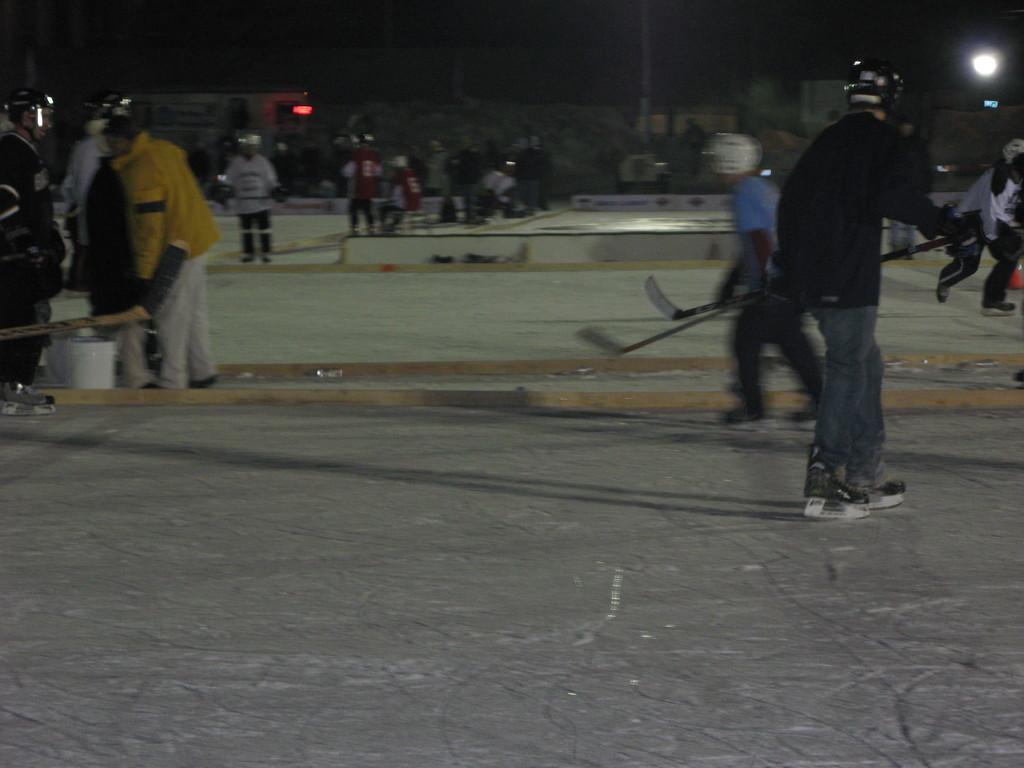In one or two sentences, can you explain what this image depicts? In this picture we can see a group of people standing on the ground were some persons wore helmets and holding bats with their hands and in the background we can see lights and it is dark. 